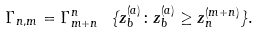<formula> <loc_0><loc_0><loc_500><loc_500>\Gamma _ { n , m } = \Gamma _ { m + n } ^ { n } \ \{ z _ { b } ^ { ( a ) } \colon z _ { b } ^ { ( a ) } \geq z _ { n } ^ { ( m + n ) } \} .</formula> 